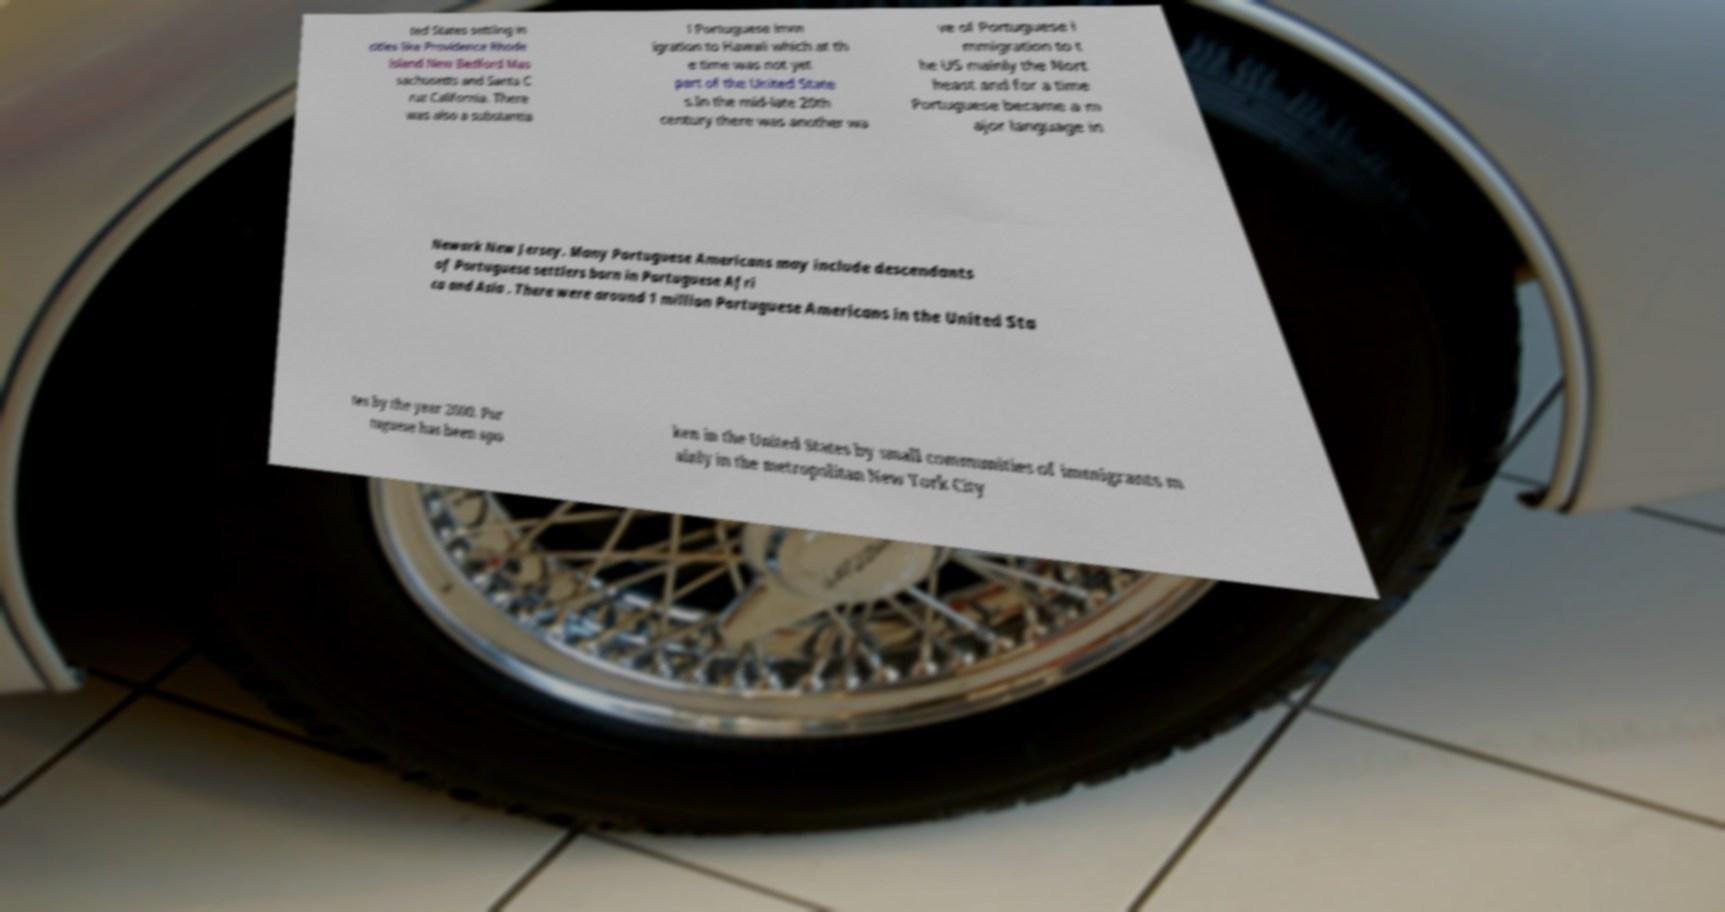Please read and relay the text visible in this image. What does it say? ted States settling in cities like Providence Rhode Island New Bedford Mas sachusetts and Santa C ruz California. There was also a substantia l Portuguese imm igration to Hawaii which at th e time was not yet part of the United State s.In the mid-late 20th century there was another wa ve of Portuguese i mmigration to t he US mainly the Nort heast and for a time Portuguese became a m ajor language in Newark New Jersey. Many Portuguese Americans may include descendants of Portuguese settlers born in Portuguese Afri ca and Asia . There were around 1 million Portuguese Americans in the United Sta tes by the year 2000. Por tuguese has been spo ken in the United States by small communities of immigrants m ainly in the metropolitan New York City 